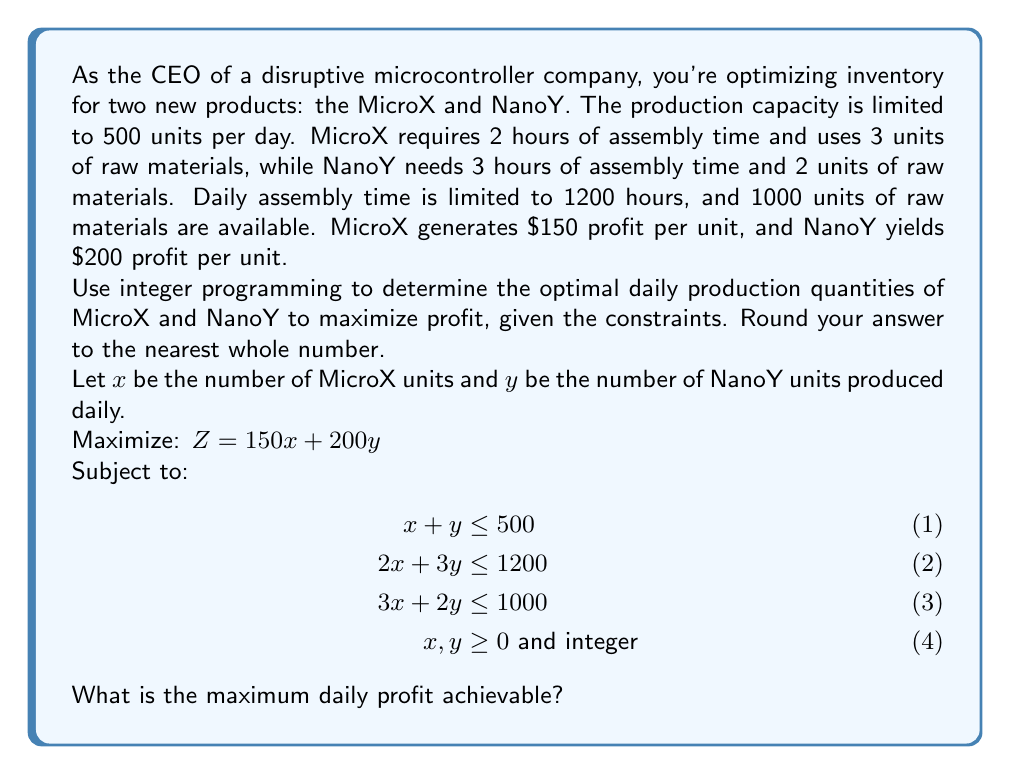Show me your answer to this math problem. To solve this integer programming problem, we'll use the following steps:

1) First, we'll solve the linear programming relaxation (ignoring the integer constraint) using the simplex method or graphical method.

2) Using the graphical method, we plot the constraints:

   [asy]
   import geometry;
   
   size(200);
   
   real xmax = 500;
   real ymax = 500;
   
   xaxis("x", 0, xmax, arrow=Arrow);
   yaxis("y", 0, ymax, arrow=Arrow);
   
   path p1 = (0,500)--(500,0);
   path p2 = (0,400)--(600,0);
   path p3 = (0,500)--(333.33,0);
   
   draw(p1, blue);
   draw(p2, red);
   draw(p3, green);
   
   label("x + y = 500", (250,250), N, blue);
   label("2x + 3y = 1200", (300,200), N, red);
   label("3x + 2y = 1000", (166.67,250), N, green);
   
   dot((200,300), purple);
   label("(200, 300)", (200,300), NE, purple);
   [/asy]

3) The feasible region is the area bounded by these constraints. The optimal solution will be at one of the corner points of this region.

4) The corner points are:
   (0, 0), (0, 400), (200, 300), (333.33, 0), (500, 0)

5) Evaluating the objective function at these points:
   Z(0, 0) = 0
   Z(0, 400) = 80,000
   Z(200, 300) = 90,000
   Z(333.33, 0) ≈ 50,000
   Z(500, 0) = 75,000

6) The maximum value is at (200, 300), giving a profit of $90,000.

7) However, we need integer solutions. The nearest integer points are:
   (200, 300), (201, 299), (199, 301), (200, 299), (199, 300)

8) Evaluating these:
   Z(200, 300) = 90,000
   Z(201, 299) = 89,950
   Z(199, 301) = 90,050
   Z(200, 299) = 89,800
   Z(199, 300) = 89,850

9) The optimal integer solution is (199, 301), giving a maximum profit of $90,050.
Answer: $90,050 